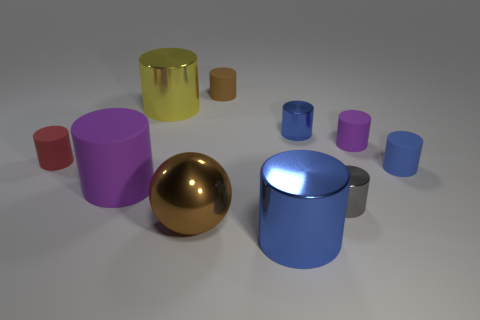What is the small purple object made of?
Give a very brief answer. Rubber. Are the large purple object and the small brown cylinder made of the same material?
Your answer should be very brief. Yes. What number of rubber things are tiny blue objects or big purple things?
Offer a terse response. 2. What shape is the tiny blue object that is on the right side of the small purple matte object?
Your answer should be very brief. Cylinder. The red cylinder that is made of the same material as the brown cylinder is what size?
Offer a terse response. Small. The big shiny object that is both in front of the big purple rubber object and behind the big blue object has what shape?
Provide a succinct answer. Sphere. There is a tiny matte cylinder that is behind the small purple matte thing; is its color the same as the large sphere?
Offer a terse response. Yes. There is a blue thing in front of the blue rubber cylinder; does it have the same shape as the purple rubber object behind the blue matte cylinder?
Provide a succinct answer. Yes. How big is the red matte cylinder that is on the left side of the big yellow metal object?
Your answer should be compact. Small. There is a blue rubber cylinder that is to the right of the blue metallic object that is in front of the gray cylinder; what size is it?
Provide a succinct answer. Small. 